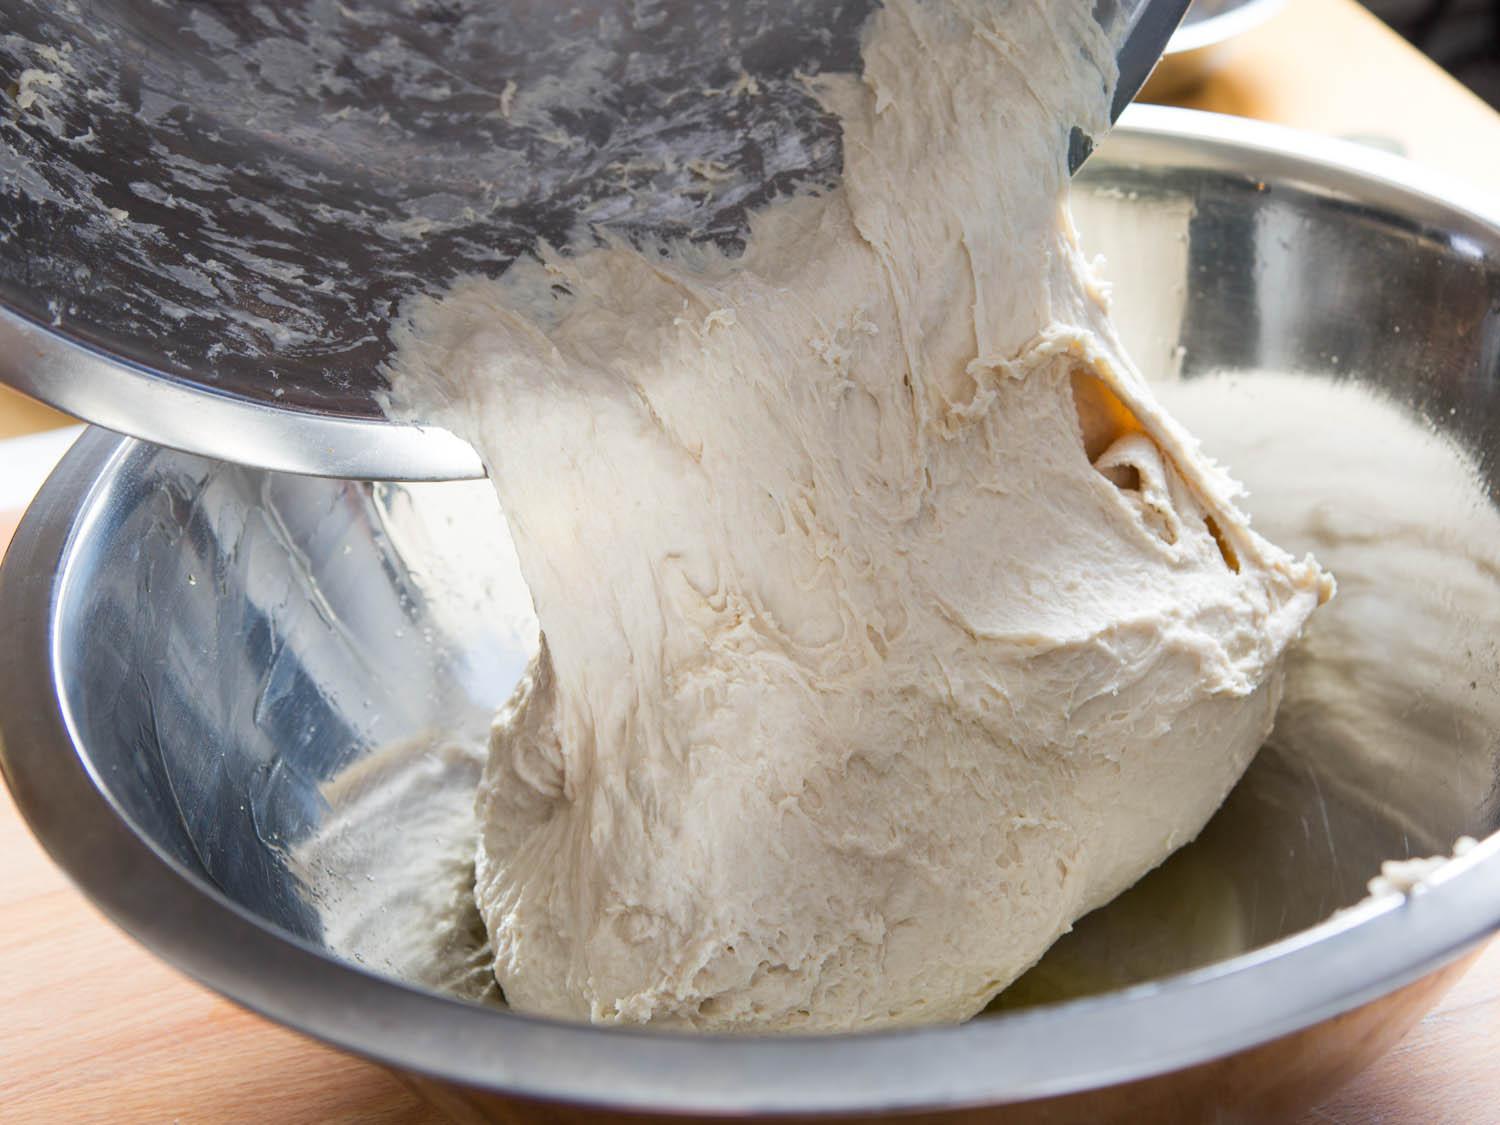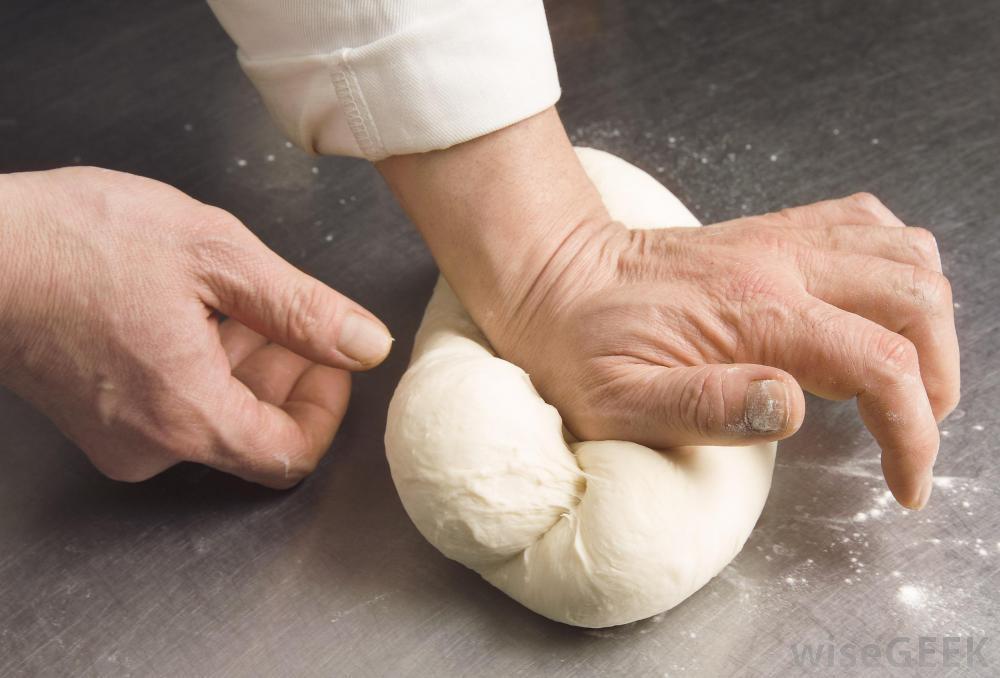The first image is the image on the left, the second image is the image on the right. Examine the images to the left and right. Is the description "One of the images shows a pair of hands kneading dough and the other image shows a ball of dough in a bowl." accurate? Answer yes or no. Yes. The first image is the image on the left, the second image is the image on the right. For the images displayed, is the sentence "Exactly one ball of dough is on a table." factually correct? Answer yes or no. Yes. 